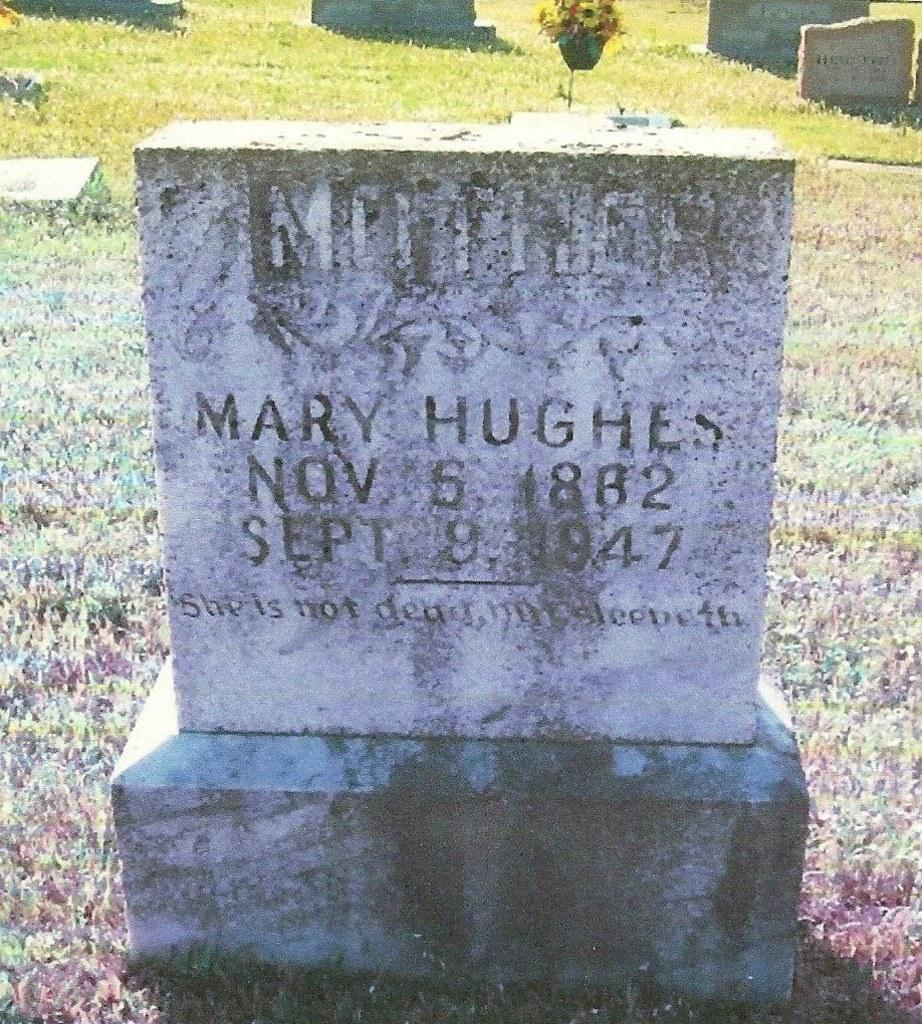What is the main object on the path in the image? There is a headstone on a path in the image. Are there any other similar objects visible in the image? Yes, there are other headstones visible behind the first headstone. What type of nut is being used as a decoration on the headstone? There is no nut present on the headstone in the image. Can you tell me who the owner of the headstone is? The image does not provide any information about the owner of the headstone. 